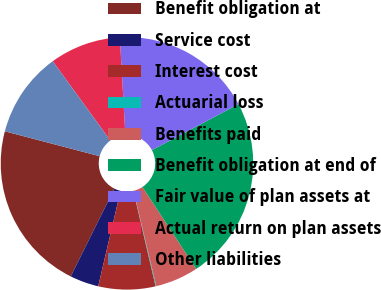Convert chart to OTSL. <chart><loc_0><loc_0><loc_500><loc_500><pie_chart><fcel>Benefit obligation at<fcel>Service cost<fcel>Interest cost<fcel>Actuarial loss<fcel>Benefits paid<fcel>Benefit obligation at end of<fcel>Fair value of plan assets at<fcel>Actual return on plan assets<fcel>Other liabilities<nl><fcel>21.74%<fcel>3.69%<fcel>7.3%<fcel>0.09%<fcel>5.5%<fcel>23.54%<fcel>18.13%<fcel>9.11%<fcel>10.91%<nl></chart> 